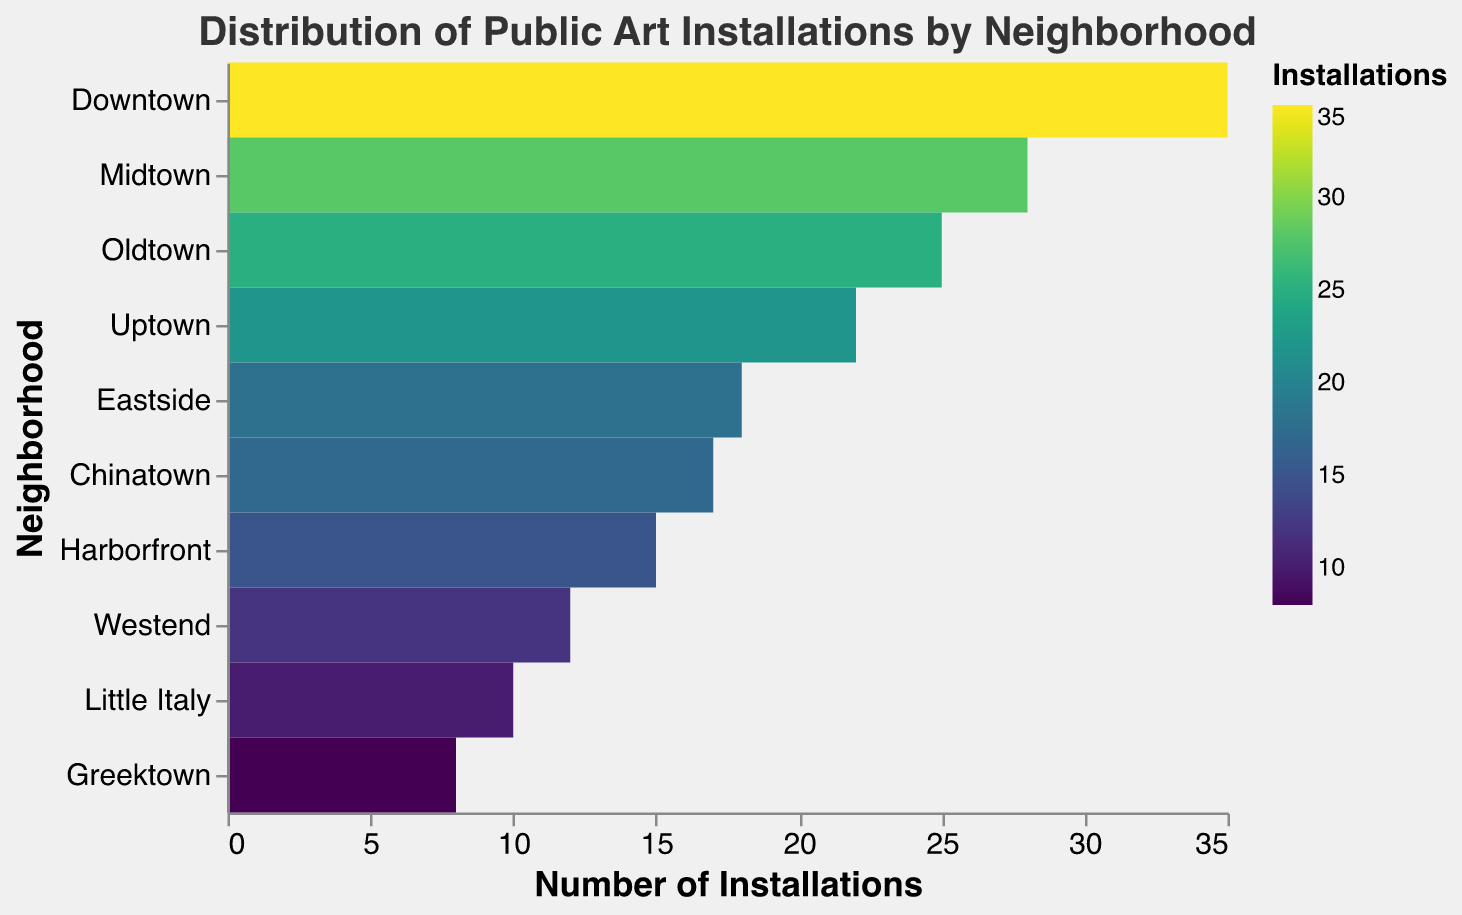What is the title of the heatmap? The title of the heatmap is displayed at the top center in a larger font, it reads "Distribution of Public Art Installations by Neighborhood".
Answer: Distribution of Public Art Installations by Neighborhood Which neighborhood has the highest number of public art installations? The heatmap uses a color scale to indicate the number of installations. The darkest color corresponds to the highest number, which is seen in the row for "Downtown".
Answer: Downtown What is the number of public art installations in Greektown? Greektown's row has a lighter color representing a lower count of installations. By referring to the x-axis, we see it falls under 8 installations.
Answer: 8 How many neighborhoods have more than 20 public art installations? Observing the colors and the x-axis, Downtown, Uptown, Midtown, and Oldtown have more than 20 installations.
Answer: 4 Which neighborhood has fewer public art installations: Eastside or Westend? Comparing the color intensities and values along the rows for Eastside (18 installations) and Westend (12 installations), Westend has fewer installations.
Answer: Westend What is the color scheme used in the heatmap? The color scheme ranging from light to dark in the legend indicates the use of "viridis" scale, with darker colors representing higher values.
Answer: Viridis What is the difference in installations between Downtown and Little Italy? Downtown has 35 installations, and Little Italy has 10. The difference can be calculated as 35 - 10.
Answer: 25 What is the average number of installations across all neighborhoods? Adding the numbers: 35 (Downtown) + 22 (Uptown) + 28 (Midtown) + 15 (Harborfront) + 12 (Westend) + 18 (Eastside) + 25 (Oldtown) + 17 (Chinatown) + 10 (Little Italy) + 8 (Greektown) = 190. Divide by the number of neighborhoods (10): 190 / 10.
Answer: 19 Which neighborhood color represents the median number of installations? The neighborhood installations in ascending order: Greektown (8), Little Italy (10), Westend (12), Harborfront (15), Chinatown (17), Eastside (18), Uptown (22), Oldtown (25), Midtown (28), Downtown (35). The median between Chinatown and Eastside (17 and 18) is closer to Eastside's color.
Answer: Eastside Are there more installations in Midtown or Oldtown? Comparing the rows' colors and corresponding x-axis values, Midtown has 28 installations while Oldtown has 25. Midtown has more installations.
Answer: Midtown 